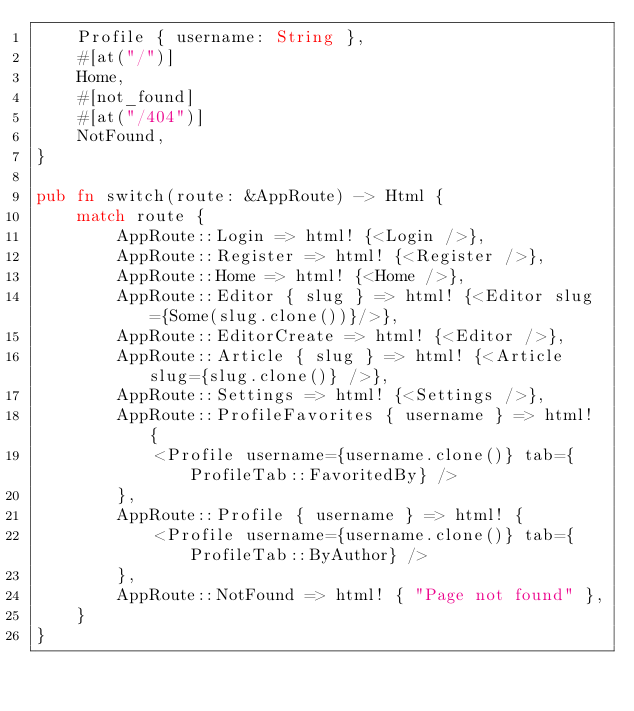<code> <loc_0><loc_0><loc_500><loc_500><_Rust_>    Profile { username: String },
    #[at("/")]
    Home,
    #[not_found]
    #[at("/404")]
    NotFound,
}

pub fn switch(route: &AppRoute) -> Html {
    match route {
        AppRoute::Login => html! {<Login />},
        AppRoute::Register => html! {<Register />},
        AppRoute::Home => html! {<Home />},
        AppRoute::Editor { slug } => html! {<Editor slug={Some(slug.clone())}/>},
        AppRoute::EditorCreate => html! {<Editor />},
        AppRoute::Article { slug } => html! {<Article slug={slug.clone()} />},
        AppRoute::Settings => html! {<Settings />},
        AppRoute::ProfileFavorites { username } => html! {
            <Profile username={username.clone()} tab={ProfileTab::FavoritedBy} />
        },
        AppRoute::Profile { username } => html! {
            <Profile username={username.clone()} tab={ProfileTab::ByAuthor} />
        },
        AppRoute::NotFound => html! { "Page not found" },
    }
}
</code> 